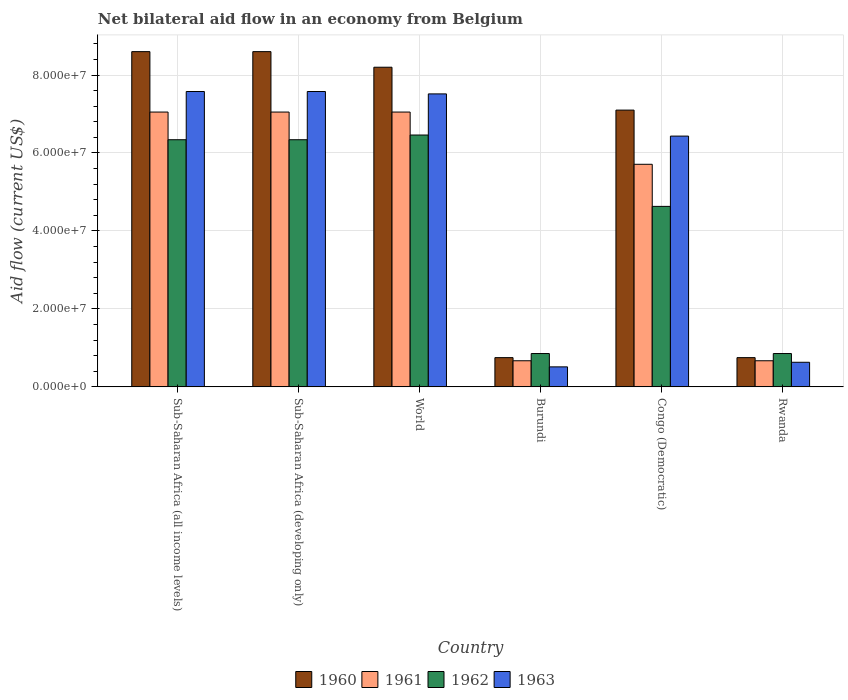Are the number of bars per tick equal to the number of legend labels?
Provide a succinct answer. Yes. Are the number of bars on each tick of the X-axis equal?
Provide a short and direct response. Yes. How many bars are there on the 4th tick from the left?
Your answer should be very brief. 4. What is the label of the 4th group of bars from the left?
Give a very brief answer. Burundi. What is the net bilateral aid flow in 1963 in Burundi?
Keep it short and to the point. 5.13e+06. Across all countries, what is the maximum net bilateral aid flow in 1961?
Give a very brief answer. 7.05e+07. Across all countries, what is the minimum net bilateral aid flow in 1962?
Your response must be concise. 8.55e+06. In which country was the net bilateral aid flow in 1960 maximum?
Make the answer very short. Sub-Saharan Africa (all income levels). In which country was the net bilateral aid flow in 1960 minimum?
Your answer should be very brief. Burundi. What is the total net bilateral aid flow in 1961 in the graph?
Make the answer very short. 2.82e+08. What is the difference between the net bilateral aid flow in 1963 in Congo (Democratic) and that in World?
Keep it short and to the point. -1.08e+07. What is the difference between the net bilateral aid flow in 1962 in Congo (Democratic) and the net bilateral aid flow in 1963 in Sub-Saharan Africa (all income levels)?
Provide a short and direct response. -2.95e+07. What is the average net bilateral aid flow in 1963 per country?
Your answer should be compact. 5.04e+07. What is the difference between the net bilateral aid flow of/in 1961 and net bilateral aid flow of/in 1963 in Sub-Saharan Africa (all income levels)?
Keep it short and to the point. -5.27e+06. What is the ratio of the net bilateral aid flow in 1960 in Congo (Democratic) to that in Sub-Saharan Africa (all income levels)?
Offer a very short reply. 0.83. What is the difference between the highest and the second highest net bilateral aid flow in 1962?
Your answer should be very brief. 1.21e+06. What is the difference between the highest and the lowest net bilateral aid flow in 1962?
Keep it short and to the point. 5.61e+07. In how many countries, is the net bilateral aid flow in 1960 greater than the average net bilateral aid flow in 1960 taken over all countries?
Your answer should be compact. 4. Is the sum of the net bilateral aid flow in 1961 in Burundi and Sub-Saharan Africa (developing only) greater than the maximum net bilateral aid flow in 1963 across all countries?
Make the answer very short. Yes. How many bars are there?
Provide a succinct answer. 24. How many countries are there in the graph?
Your answer should be very brief. 6. What is the difference between two consecutive major ticks on the Y-axis?
Your response must be concise. 2.00e+07. Are the values on the major ticks of Y-axis written in scientific E-notation?
Your answer should be very brief. Yes. Does the graph contain any zero values?
Ensure brevity in your answer.  No. Does the graph contain grids?
Keep it short and to the point. Yes. Where does the legend appear in the graph?
Keep it short and to the point. Bottom center. What is the title of the graph?
Offer a terse response. Net bilateral aid flow in an economy from Belgium. Does "2002" appear as one of the legend labels in the graph?
Keep it short and to the point. No. What is the label or title of the X-axis?
Provide a succinct answer. Country. What is the label or title of the Y-axis?
Your response must be concise. Aid flow (current US$). What is the Aid flow (current US$) in 1960 in Sub-Saharan Africa (all income levels)?
Provide a succinct answer. 8.60e+07. What is the Aid flow (current US$) of 1961 in Sub-Saharan Africa (all income levels)?
Ensure brevity in your answer.  7.05e+07. What is the Aid flow (current US$) of 1962 in Sub-Saharan Africa (all income levels)?
Offer a terse response. 6.34e+07. What is the Aid flow (current US$) of 1963 in Sub-Saharan Africa (all income levels)?
Offer a very short reply. 7.58e+07. What is the Aid flow (current US$) of 1960 in Sub-Saharan Africa (developing only)?
Provide a short and direct response. 8.60e+07. What is the Aid flow (current US$) in 1961 in Sub-Saharan Africa (developing only)?
Your answer should be very brief. 7.05e+07. What is the Aid flow (current US$) of 1962 in Sub-Saharan Africa (developing only)?
Provide a succinct answer. 6.34e+07. What is the Aid flow (current US$) of 1963 in Sub-Saharan Africa (developing only)?
Give a very brief answer. 7.58e+07. What is the Aid flow (current US$) in 1960 in World?
Ensure brevity in your answer.  8.20e+07. What is the Aid flow (current US$) of 1961 in World?
Provide a succinct answer. 7.05e+07. What is the Aid flow (current US$) of 1962 in World?
Provide a short and direct response. 6.46e+07. What is the Aid flow (current US$) in 1963 in World?
Provide a short and direct response. 7.52e+07. What is the Aid flow (current US$) of 1960 in Burundi?
Offer a terse response. 7.50e+06. What is the Aid flow (current US$) in 1961 in Burundi?
Offer a very short reply. 6.70e+06. What is the Aid flow (current US$) of 1962 in Burundi?
Provide a short and direct response. 8.55e+06. What is the Aid flow (current US$) in 1963 in Burundi?
Offer a very short reply. 5.13e+06. What is the Aid flow (current US$) in 1960 in Congo (Democratic)?
Offer a terse response. 7.10e+07. What is the Aid flow (current US$) of 1961 in Congo (Democratic)?
Offer a very short reply. 5.71e+07. What is the Aid flow (current US$) of 1962 in Congo (Democratic)?
Offer a terse response. 4.63e+07. What is the Aid flow (current US$) of 1963 in Congo (Democratic)?
Offer a terse response. 6.43e+07. What is the Aid flow (current US$) of 1960 in Rwanda?
Provide a short and direct response. 7.50e+06. What is the Aid flow (current US$) in 1961 in Rwanda?
Your response must be concise. 6.70e+06. What is the Aid flow (current US$) of 1962 in Rwanda?
Offer a very short reply. 8.55e+06. What is the Aid flow (current US$) in 1963 in Rwanda?
Provide a succinct answer. 6.31e+06. Across all countries, what is the maximum Aid flow (current US$) in 1960?
Make the answer very short. 8.60e+07. Across all countries, what is the maximum Aid flow (current US$) in 1961?
Provide a short and direct response. 7.05e+07. Across all countries, what is the maximum Aid flow (current US$) in 1962?
Offer a terse response. 6.46e+07. Across all countries, what is the maximum Aid flow (current US$) of 1963?
Keep it short and to the point. 7.58e+07. Across all countries, what is the minimum Aid flow (current US$) in 1960?
Your response must be concise. 7.50e+06. Across all countries, what is the minimum Aid flow (current US$) in 1961?
Provide a succinct answer. 6.70e+06. Across all countries, what is the minimum Aid flow (current US$) in 1962?
Offer a terse response. 8.55e+06. Across all countries, what is the minimum Aid flow (current US$) of 1963?
Offer a terse response. 5.13e+06. What is the total Aid flow (current US$) of 1960 in the graph?
Your answer should be very brief. 3.40e+08. What is the total Aid flow (current US$) of 1961 in the graph?
Provide a short and direct response. 2.82e+08. What is the total Aid flow (current US$) in 1962 in the graph?
Offer a terse response. 2.55e+08. What is the total Aid flow (current US$) of 1963 in the graph?
Provide a succinct answer. 3.02e+08. What is the difference between the Aid flow (current US$) in 1960 in Sub-Saharan Africa (all income levels) and that in Sub-Saharan Africa (developing only)?
Your answer should be compact. 0. What is the difference between the Aid flow (current US$) in 1961 in Sub-Saharan Africa (all income levels) and that in Sub-Saharan Africa (developing only)?
Your response must be concise. 0. What is the difference between the Aid flow (current US$) in 1962 in Sub-Saharan Africa (all income levels) and that in Sub-Saharan Africa (developing only)?
Make the answer very short. 0. What is the difference between the Aid flow (current US$) of 1963 in Sub-Saharan Africa (all income levels) and that in Sub-Saharan Africa (developing only)?
Your answer should be very brief. 0. What is the difference between the Aid flow (current US$) in 1962 in Sub-Saharan Africa (all income levels) and that in World?
Offer a terse response. -1.21e+06. What is the difference between the Aid flow (current US$) in 1963 in Sub-Saharan Africa (all income levels) and that in World?
Provide a short and direct response. 6.10e+05. What is the difference between the Aid flow (current US$) of 1960 in Sub-Saharan Africa (all income levels) and that in Burundi?
Give a very brief answer. 7.85e+07. What is the difference between the Aid flow (current US$) in 1961 in Sub-Saharan Africa (all income levels) and that in Burundi?
Provide a short and direct response. 6.38e+07. What is the difference between the Aid flow (current US$) of 1962 in Sub-Saharan Africa (all income levels) and that in Burundi?
Make the answer very short. 5.48e+07. What is the difference between the Aid flow (current US$) in 1963 in Sub-Saharan Africa (all income levels) and that in Burundi?
Keep it short and to the point. 7.06e+07. What is the difference between the Aid flow (current US$) of 1960 in Sub-Saharan Africa (all income levels) and that in Congo (Democratic)?
Offer a very short reply. 1.50e+07. What is the difference between the Aid flow (current US$) in 1961 in Sub-Saharan Africa (all income levels) and that in Congo (Democratic)?
Your response must be concise. 1.34e+07. What is the difference between the Aid flow (current US$) in 1962 in Sub-Saharan Africa (all income levels) and that in Congo (Democratic)?
Ensure brevity in your answer.  1.71e+07. What is the difference between the Aid flow (current US$) of 1963 in Sub-Saharan Africa (all income levels) and that in Congo (Democratic)?
Make the answer very short. 1.14e+07. What is the difference between the Aid flow (current US$) of 1960 in Sub-Saharan Africa (all income levels) and that in Rwanda?
Offer a terse response. 7.85e+07. What is the difference between the Aid flow (current US$) of 1961 in Sub-Saharan Africa (all income levels) and that in Rwanda?
Ensure brevity in your answer.  6.38e+07. What is the difference between the Aid flow (current US$) of 1962 in Sub-Saharan Africa (all income levels) and that in Rwanda?
Your answer should be very brief. 5.48e+07. What is the difference between the Aid flow (current US$) in 1963 in Sub-Saharan Africa (all income levels) and that in Rwanda?
Ensure brevity in your answer.  6.95e+07. What is the difference between the Aid flow (current US$) in 1960 in Sub-Saharan Africa (developing only) and that in World?
Ensure brevity in your answer.  4.00e+06. What is the difference between the Aid flow (current US$) in 1961 in Sub-Saharan Africa (developing only) and that in World?
Provide a short and direct response. 0. What is the difference between the Aid flow (current US$) in 1962 in Sub-Saharan Africa (developing only) and that in World?
Your answer should be very brief. -1.21e+06. What is the difference between the Aid flow (current US$) of 1963 in Sub-Saharan Africa (developing only) and that in World?
Keep it short and to the point. 6.10e+05. What is the difference between the Aid flow (current US$) of 1960 in Sub-Saharan Africa (developing only) and that in Burundi?
Make the answer very short. 7.85e+07. What is the difference between the Aid flow (current US$) in 1961 in Sub-Saharan Africa (developing only) and that in Burundi?
Your answer should be compact. 6.38e+07. What is the difference between the Aid flow (current US$) of 1962 in Sub-Saharan Africa (developing only) and that in Burundi?
Keep it short and to the point. 5.48e+07. What is the difference between the Aid flow (current US$) of 1963 in Sub-Saharan Africa (developing only) and that in Burundi?
Give a very brief answer. 7.06e+07. What is the difference between the Aid flow (current US$) in 1960 in Sub-Saharan Africa (developing only) and that in Congo (Democratic)?
Give a very brief answer. 1.50e+07. What is the difference between the Aid flow (current US$) in 1961 in Sub-Saharan Africa (developing only) and that in Congo (Democratic)?
Make the answer very short. 1.34e+07. What is the difference between the Aid flow (current US$) of 1962 in Sub-Saharan Africa (developing only) and that in Congo (Democratic)?
Offer a very short reply. 1.71e+07. What is the difference between the Aid flow (current US$) of 1963 in Sub-Saharan Africa (developing only) and that in Congo (Democratic)?
Offer a terse response. 1.14e+07. What is the difference between the Aid flow (current US$) of 1960 in Sub-Saharan Africa (developing only) and that in Rwanda?
Provide a short and direct response. 7.85e+07. What is the difference between the Aid flow (current US$) of 1961 in Sub-Saharan Africa (developing only) and that in Rwanda?
Make the answer very short. 6.38e+07. What is the difference between the Aid flow (current US$) of 1962 in Sub-Saharan Africa (developing only) and that in Rwanda?
Provide a succinct answer. 5.48e+07. What is the difference between the Aid flow (current US$) in 1963 in Sub-Saharan Africa (developing only) and that in Rwanda?
Ensure brevity in your answer.  6.95e+07. What is the difference between the Aid flow (current US$) of 1960 in World and that in Burundi?
Keep it short and to the point. 7.45e+07. What is the difference between the Aid flow (current US$) of 1961 in World and that in Burundi?
Provide a short and direct response. 6.38e+07. What is the difference between the Aid flow (current US$) in 1962 in World and that in Burundi?
Offer a terse response. 5.61e+07. What is the difference between the Aid flow (current US$) in 1963 in World and that in Burundi?
Keep it short and to the point. 7.00e+07. What is the difference between the Aid flow (current US$) in 1960 in World and that in Congo (Democratic)?
Ensure brevity in your answer.  1.10e+07. What is the difference between the Aid flow (current US$) of 1961 in World and that in Congo (Democratic)?
Offer a very short reply. 1.34e+07. What is the difference between the Aid flow (current US$) in 1962 in World and that in Congo (Democratic)?
Offer a very short reply. 1.83e+07. What is the difference between the Aid flow (current US$) in 1963 in World and that in Congo (Democratic)?
Make the answer very short. 1.08e+07. What is the difference between the Aid flow (current US$) in 1960 in World and that in Rwanda?
Provide a succinct answer. 7.45e+07. What is the difference between the Aid flow (current US$) in 1961 in World and that in Rwanda?
Give a very brief answer. 6.38e+07. What is the difference between the Aid flow (current US$) of 1962 in World and that in Rwanda?
Offer a very short reply. 5.61e+07. What is the difference between the Aid flow (current US$) of 1963 in World and that in Rwanda?
Provide a succinct answer. 6.88e+07. What is the difference between the Aid flow (current US$) in 1960 in Burundi and that in Congo (Democratic)?
Offer a terse response. -6.35e+07. What is the difference between the Aid flow (current US$) in 1961 in Burundi and that in Congo (Democratic)?
Provide a short and direct response. -5.04e+07. What is the difference between the Aid flow (current US$) of 1962 in Burundi and that in Congo (Democratic)?
Ensure brevity in your answer.  -3.78e+07. What is the difference between the Aid flow (current US$) in 1963 in Burundi and that in Congo (Democratic)?
Make the answer very short. -5.92e+07. What is the difference between the Aid flow (current US$) of 1963 in Burundi and that in Rwanda?
Give a very brief answer. -1.18e+06. What is the difference between the Aid flow (current US$) in 1960 in Congo (Democratic) and that in Rwanda?
Provide a succinct answer. 6.35e+07. What is the difference between the Aid flow (current US$) in 1961 in Congo (Democratic) and that in Rwanda?
Ensure brevity in your answer.  5.04e+07. What is the difference between the Aid flow (current US$) in 1962 in Congo (Democratic) and that in Rwanda?
Ensure brevity in your answer.  3.78e+07. What is the difference between the Aid flow (current US$) of 1963 in Congo (Democratic) and that in Rwanda?
Offer a terse response. 5.80e+07. What is the difference between the Aid flow (current US$) of 1960 in Sub-Saharan Africa (all income levels) and the Aid flow (current US$) of 1961 in Sub-Saharan Africa (developing only)?
Offer a terse response. 1.55e+07. What is the difference between the Aid flow (current US$) in 1960 in Sub-Saharan Africa (all income levels) and the Aid flow (current US$) in 1962 in Sub-Saharan Africa (developing only)?
Your answer should be compact. 2.26e+07. What is the difference between the Aid flow (current US$) of 1960 in Sub-Saharan Africa (all income levels) and the Aid flow (current US$) of 1963 in Sub-Saharan Africa (developing only)?
Provide a short and direct response. 1.02e+07. What is the difference between the Aid flow (current US$) of 1961 in Sub-Saharan Africa (all income levels) and the Aid flow (current US$) of 1962 in Sub-Saharan Africa (developing only)?
Your answer should be compact. 7.10e+06. What is the difference between the Aid flow (current US$) in 1961 in Sub-Saharan Africa (all income levels) and the Aid flow (current US$) in 1963 in Sub-Saharan Africa (developing only)?
Offer a very short reply. -5.27e+06. What is the difference between the Aid flow (current US$) of 1962 in Sub-Saharan Africa (all income levels) and the Aid flow (current US$) of 1963 in Sub-Saharan Africa (developing only)?
Make the answer very short. -1.24e+07. What is the difference between the Aid flow (current US$) in 1960 in Sub-Saharan Africa (all income levels) and the Aid flow (current US$) in 1961 in World?
Ensure brevity in your answer.  1.55e+07. What is the difference between the Aid flow (current US$) in 1960 in Sub-Saharan Africa (all income levels) and the Aid flow (current US$) in 1962 in World?
Keep it short and to the point. 2.14e+07. What is the difference between the Aid flow (current US$) of 1960 in Sub-Saharan Africa (all income levels) and the Aid flow (current US$) of 1963 in World?
Provide a succinct answer. 1.08e+07. What is the difference between the Aid flow (current US$) in 1961 in Sub-Saharan Africa (all income levels) and the Aid flow (current US$) in 1962 in World?
Ensure brevity in your answer.  5.89e+06. What is the difference between the Aid flow (current US$) of 1961 in Sub-Saharan Africa (all income levels) and the Aid flow (current US$) of 1963 in World?
Offer a terse response. -4.66e+06. What is the difference between the Aid flow (current US$) in 1962 in Sub-Saharan Africa (all income levels) and the Aid flow (current US$) in 1963 in World?
Provide a succinct answer. -1.18e+07. What is the difference between the Aid flow (current US$) of 1960 in Sub-Saharan Africa (all income levels) and the Aid flow (current US$) of 1961 in Burundi?
Ensure brevity in your answer.  7.93e+07. What is the difference between the Aid flow (current US$) of 1960 in Sub-Saharan Africa (all income levels) and the Aid flow (current US$) of 1962 in Burundi?
Offer a terse response. 7.74e+07. What is the difference between the Aid flow (current US$) in 1960 in Sub-Saharan Africa (all income levels) and the Aid flow (current US$) in 1963 in Burundi?
Your response must be concise. 8.09e+07. What is the difference between the Aid flow (current US$) in 1961 in Sub-Saharan Africa (all income levels) and the Aid flow (current US$) in 1962 in Burundi?
Provide a short and direct response. 6.20e+07. What is the difference between the Aid flow (current US$) of 1961 in Sub-Saharan Africa (all income levels) and the Aid flow (current US$) of 1963 in Burundi?
Make the answer very short. 6.54e+07. What is the difference between the Aid flow (current US$) in 1962 in Sub-Saharan Africa (all income levels) and the Aid flow (current US$) in 1963 in Burundi?
Offer a very short reply. 5.83e+07. What is the difference between the Aid flow (current US$) in 1960 in Sub-Saharan Africa (all income levels) and the Aid flow (current US$) in 1961 in Congo (Democratic)?
Offer a very short reply. 2.89e+07. What is the difference between the Aid flow (current US$) in 1960 in Sub-Saharan Africa (all income levels) and the Aid flow (current US$) in 1962 in Congo (Democratic)?
Your response must be concise. 3.97e+07. What is the difference between the Aid flow (current US$) in 1960 in Sub-Saharan Africa (all income levels) and the Aid flow (current US$) in 1963 in Congo (Democratic)?
Give a very brief answer. 2.17e+07. What is the difference between the Aid flow (current US$) in 1961 in Sub-Saharan Africa (all income levels) and the Aid flow (current US$) in 1962 in Congo (Democratic)?
Keep it short and to the point. 2.42e+07. What is the difference between the Aid flow (current US$) of 1961 in Sub-Saharan Africa (all income levels) and the Aid flow (current US$) of 1963 in Congo (Democratic)?
Provide a succinct answer. 6.17e+06. What is the difference between the Aid flow (current US$) in 1962 in Sub-Saharan Africa (all income levels) and the Aid flow (current US$) in 1963 in Congo (Democratic)?
Your answer should be compact. -9.30e+05. What is the difference between the Aid flow (current US$) in 1960 in Sub-Saharan Africa (all income levels) and the Aid flow (current US$) in 1961 in Rwanda?
Provide a short and direct response. 7.93e+07. What is the difference between the Aid flow (current US$) of 1960 in Sub-Saharan Africa (all income levels) and the Aid flow (current US$) of 1962 in Rwanda?
Give a very brief answer. 7.74e+07. What is the difference between the Aid flow (current US$) in 1960 in Sub-Saharan Africa (all income levels) and the Aid flow (current US$) in 1963 in Rwanda?
Provide a short and direct response. 7.97e+07. What is the difference between the Aid flow (current US$) in 1961 in Sub-Saharan Africa (all income levels) and the Aid flow (current US$) in 1962 in Rwanda?
Give a very brief answer. 6.20e+07. What is the difference between the Aid flow (current US$) of 1961 in Sub-Saharan Africa (all income levels) and the Aid flow (current US$) of 1963 in Rwanda?
Your response must be concise. 6.42e+07. What is the difference between the Aid flow (current US$) of 1962 in Sub-Saharan Africa (all income levels) and the Aid flow (current US$) of 1963 in Rwanda?
Offer a very short reply. 5.71e+07. What is the difference between the Aid flow (current US$) in 1960 in Sub-Saharan Africa (developing only) and the Aid flow (current US$) in 1961 in World?
Keep it short and to the point. 1.55e+07. What is the difference between the Aid flow (current US$) of 1960 in Sub-Saharan Africa (developing only) and the Aid flow (current US$) of 1962 in World?
Make the answer very short. 2.14e+07. What is the difference between the Aid flow (current US$) of 1960 in Sub-Saharan Africa (developing only) and the Aid flow (current US$) of 1963 in World?
Your response must be concise. 1.08e+07. What is the difference between the Aid flow (current US$) in 1961 in Sub-Saharan Africa (developing only) and the Aid flow (current US$) in 1962 in World?
Offer a very short reply. 5.89e+06. What is the difference between the Aid flow (current US$) of 1961 in Sub-Saharan Africa (developing only) and the Aid flow (current US$) of 1963 in World?
Provide a succinct answer. -4.66e+06. What is the difference between the Aid flow (current US$) in 1962 in Sub-Saharan Africa (developing only) and the Aid flow (current US$) in 1963 in World?
Provide a short and direct response. -1.18e+07. What is the difference between the Aid flow (current US$) of 1960 in Sub-Saharan Africa (developing only) and the Aid flow (current US$) of 1961 in Burundi?
Offer a terse response. 7.93e+07. What is the difference between the Aid flow (current US$) in 1960 in Sub-Saharan Africa (developing only) and the Aid flow (current US$) in 1962 in Burundi?
Make the answer very short. 7.74e+07. What is the difference between the Aid flow (current US$) of 1960 in Sub-Saharan Africa (developing only) and the Aid flow (current US$) of 1963 in Burundi?
Offer a terse response. 8.09e+07. What is the difference between the Aid flow (current US$) in 1961 in Sub-Saharan Africa (developing only) and the Aid flow (current US$) in 1962 in Burundi?
Offer a very short reply. 6.20e+07. What is the difference between the Aid flow (current US$) of 1961 in Sub-Saharan Africa (developing only) and the Aid flow (current US$) of 1963 in Burundi?
Give a very brief answer. 6.54e+07. What is the difference between the Aid flow (current US$) of 1962 in Sub-Saharan Africa (developing only) and the Aid flow (current US$) of 1963 in Burundi?
Ensure brevity in your answer.  5.83e+07. What is the difference between the Aid flow (current US$) in 1960 in Sub-Saharan Africa (developing only) and the Aid flow (current US$) in 1961 in Congo (Democratic)?
Make the answer very short. 2.89e+07. What is the difference between the Aid flow (current US$) in 1960 in Sub-Saharan Africa (developing only) and the Aid flow (current US$) in 1962 in Congo (Democratic)?
Give a very brief answer. 3.97e+07. What is the difference between the Aid flow (current US$) in 1960 in Sub-Saharan Africa (developing only) and the Aid flow (current US$) in 1963 in Congo (Democratic)?
Make the answer very short. 2.17e+07. What is the difference between the Aid flow (current US$) in 1961 in Sub-Saharan Africa (developing only) and the Aid flow (current US$) in 1962 in Congo (Democratic)?
Offer a terse response. 2.42e+07. What is the difference between the Aid flow (current US$) of 1961 in Sub-Saharan Africa (developing only) and the Aid flow (current US$) of 1963 in Congo (Democratic)?
Your response must be concise. 6.17e+06. What is the difference between the Aid flow (current US$) in 1962 in Sub-Saharan Africa (developing only) and the Aid flow (current US$) in 1963 in Congo (Democratic)?
Keep it short and to the point. -9.30e+05. What is the difference between the Aid flow (current US$) in 1960 in Sub-Saharan Africa (developing only) and the Aid flow (current US$) in 1961 in Rwanda?
Provide a succinct answer. 7.93e+07. What is the difference between the Aid flow (current US$) of 1960 in Sub-Saharan Africa (developing only) and the Aid flow (current US$) of 1962 in Rwanda?
Your response must be concise. 7.74e+07. What is the difference between the Aid flow (current US$) of 1960 in Sub-Saharan Africa (developing only) and the Aid flow (current US$) of 1963 in Rwanda?
Your response must be concise. 7.97e+07. What is the difference between the Aid flow (current US$) in 1961 in Sub-Saharan Africa (developing only) and the Aid flow (current US$) in 1962 in Rwanda?
Keep it short and to the point. 6.20e+07. What is the difference between the Aid flow (current US$) in 1961 in Sub-Saharan Africa (developing only) and the Aid flow (current US$) in 1963 in Rwanda?
Offer a very short reply. 6.42e+07. What is the difference between the Aid flow (current US$) in 1962 in Sub-Saharan Africa (developing only) and the Aid flow (current US$) in 1963 in Rwanda?
Offer a terse response. 5.71e+07. What is the difference between the Aid flow (current US$) in 1960 in World and the Aid flow (current US$) in 1961 in Burundi?
Your answer should be compact. 7.53e+07. What is the difference between the Aid flow (current US$) in 1960 in World and the Aid flow (current US$) in 1962 in Burundi?
Ensure brevity in your answer.  7.34e+07. What is the difference between the Aid flow (current US$) of 1960 in World and the Aid flow (current US$) of 1963 in Burundi?
Offer a very short reply. 7.69e+07. What is the difference between the Aid flow (current US$) in 1961 in World and the Aid flow (current US$) in 1962 in Burundi?
Your answer should be very brief. 6.20e+07. What is the difference between the Aid flow (current US$) of 1961 in World and the Aid flow (current US$) of 1963 in Burundi?
Your response must be concise. 6.54e+07. What is the difference between the Aid flow (current US$) of 1962 in World and the Aid flow (current US$) of 1963 in Burundi?
Your answer should be compact. 5.95e+07. What is the difference between the Aid flow (current US$) of 1960 in World and the Aid flow (current US$) of 1961 in Congo (Democratic)?
Your answer should be compact. 2.49e+07. What is the difference between the Aid flow (current US$) of 1960 in World and the Aid flow (current US$) of 1962 in Congo (Democratic)?
Provide a succinct answer. 3.57e+07. What is the difference between the Aid flow (current US$) of 1960 in World and the Aid flow (current US$) of 1963 in Congo (Democratic)?
Make the answer very short. 1.77e+07. What is the difference between the Aid flow (current US$) of 1961 in World and the Aid flow (current US$) of 1962 in Congo (Democratic)?
Keep it short and to the point. 2.42e+07. What is the difference between the Aid flow (current US$) in 1961 in World and the Aid flow (current US$) in 1963 in Congo (Democratic)?
Give a very brief answer. 6.17e+06. What is the difference between the Aid flow (current US$) of 1960 in World and the Aid flow (current US$) of 1961 in Rwanda?
Offer a very short reply. 7.53e+07. What is the difference between the Aid flow (current US$) of 1960 in World and the Aid flow (current US$) of 1962 in Rwanda?
Keep it short and to the point. 7.34e+07. What is the difference between the Aid flow (current US$) in 1960 in World and the Aid flow (current US$) in 1963 in Rwanda?
Ensure brevity in your answer.  7.57e+07. What is the difference between the Aid flow (current US$) of 1961 in World and the Aid flow (current US$) of 1962 in Rwanda?
Your response must be concise. 6.20e+07. What is the difference between the Aid flow (current US$) of 1961 in World and the Aid flow (current US$) of 1963 in Rwanda?
Your answer should be compact. 6.42e+07. What is the difference between the Aid flow (current US$) of 1962 in World and the Aid flow (current US$) of 1963 in Rwanda?
Your response must be concise. 5.83e+07. What is the difference between the Aid flow (current US$) in 1960 in Burundi and the Aid flow (current US$) in 1961 in Congo (Democratic)?
Provide a succinct answer. -4.96e+07. What is the difference between the Aid flow (current US$) of 1960 in Burundi and the Aid flow (current US$) of 1962 in Congo (Democratic)?
Ensure brevity in your answer.  -3.88e+07. What is the difference between the Aid flow (current US$) in 1960 in Burundi and the Aid flow (current US$) in 1963 in Congo (Democratic)?
Give a very brief answer. -5.68e+07. What is the difference between the Aid flow (current US$) of 1961 in Burundi and the Aid flow (current US$) of 1962 in Congo (Democratic)?
Provide a succinct answer. -3.96e+07. What is the difference between the Aid flow (current US$) of 1961 in Burundi and the Aid flow (current US$) of 1963 in Congo (Democratic)?
Give a very brief answer. -5.76e+07. What is the difference between the Aid flow (current US$) in 1962 in Burundi and the Aid flow (current US$) in 1963 in Congo (Democratic)?
Provide a succinct answer. -5.58e+07. What is the difference between the Aid flow (current US$) in 1960 in Burundi and the Aid flow (current US$) in 1962 in Rwanda?
Provide a succinct answer. -1.05e+06. What is the difference between the Aid flow (current US$) in 1960 in Burundi and the Aid flow (current US$) in 1963 in Rwanda?
Your answer should be compact. 1.19e+06. What is the difference between the Aid flow (current US$) in 1961 in Burundi and the Aid flow (current US$) in 1962 in Rwanda?
Your response must be concise. -1.85e+06. What is the difference between the Aid flow (current US$) in 1962 in Burundi and the Aid flow (current US$) in 1963 in Rwanda?
Give a very brief answer. 2.24e+06. What is the difference between the Aid flow (current US$) in 1960 in Congo (Democratic) and the Aid flow (current US$) in 1961 in Rwanda?
Provide a short and direct response. 6.43e+07. What is the difference between the Aid flow (current US$) in 1960 in Congo (Democratic) and the Aid flow (current US$) in 1962 in Rwanda?
Give a very brief answer. 6.24e+07. What is the difference between the Aid flow (current US$) in 1960 in Congo (Democratic) and the Aid flow (current US$) in 1963 in Rwanda?
Give a very brief answer. 6.47e+07. What is the difference between the Aid flow (current US$) in 1961 in Congo (Democratic) and the Aid flow (current US$) in 1962 in Rwanda?
Your answer should be very brief. 4.86e+07. What is the difference between the Aid flow (current US$) of 1961 in Congo (Democratic) and the Aid flow (current US$) of 1963 in Rwanda?
Provide a succinct answer. 5.08e+07. What is the difference between the Aid flow (current US$) of 1962 in Congo (Democratic) and the Aid flow (current US$) of 1963 in Rwanda?
Make the answer very short. 4.00e+07. What is the average Aid flow (current US$) in 1960 per country?
Provide a short and direct response. 5.67e+07. What is the average Aid flow (current US$) of 1961 per country?
Keep it short and to the point. 4.70e+07. What is the average Aid flow (current US$) in 1962 per country?
Give a very brief answer. 4.25e+07. What is the average Aid flow (current US$) of 1963 per country?
Provide a succinct answer. 5.04e+07. What is the difference between the Aid flow (current US$) of 1960 and Aid flow (current US$) of 1961 in Sub-Saharan Africa (all income levels)?
Make the answer very short. 1.55e+07. What is the difference between the Aid flow (current US$) in 1960 and Aid flow (current US$) in 1962 in Sub-Saharan Africa (all income levels)?
Make the answer very short. 2.26e+07. What is the difference between the Aid flow (current US$) in 1960 and Aid flow (current US$) in 1963 in Sub-Saharan Africa (all income levels)?
Offer a terse response. 1.02e+07. What is the difference between the Aid flow (current US$) in 1961 and Aid flow (current US$) in 1962 in Sub-Saharan Africa (all income levels)?
Make the answer very short. 7.10e+06. What is the difference between the Aid flow (current US$) of 1961 and Aid flow (current US$) of 1963 in Sub-Saharan Africa (all income levels)?
Keep it short and to the point. -5.27e+06. What is the difference between the Aid flow (current US$) of 1962 and Aid flow (current US$) of 1963 in Sub-Saharan Africa (all income levels)?
Provide a succinct answer. -1.24e+07. What is the difference between the Aid flow (current US$) in 1960 and Aid flow (current US$) in 1961 in Sub-Saharan Africa (developing only)?
Ensure brevity in your answer.  1.55e+07. What is the difference between the Aid flow (current US$) in 1960 and Aid flow (current US$) in 1962 in Sub-Saharan Africa (developing only)?
Offer a terse response. 2.26e+07. What is the difference between the Aid flow (current US$) of 1960 and Aid flow (current US$) of 1963 in Sub-Saharan Africa (developing only)?
Make the answer very short. 1.02e+07. What is the difference between the Aid flow (current US$) of 1961 and Aid flow (current US$) of 1962 in Sub-Saharan Africa (developing only)?
Your answer should be compact. 7.10e+06. What is the difference between the Aid flow (current US$) in 1961 and Aid flow (current US$) in 1963 in Sub-Saharan Africa (developing only)?
Provide a short and direct response. -5.27e+06. What is the difference between the Aid flow (current US$) in 1962 and Aid flow (current US$) in 1963 in Sub-Saharan Africa (developing only)?
Make the answer very short. -1.24e+07. What is the difference between the Aid flow (current US$) in 1960 and Aid flow (current US$) in 1961 in World?
Provide a short and direct response. 1.15e+07. What is the difference between the Aid flow (current US$) of 1960 and Aid flow (current US$) of 1962 in World?
Keep it short and to the point. 1.74e+07. What is the difference between the Aid flow (current US$) in 1960 and Aid flow (current US$) in 1963 in World?
Make the answer very short. 6.84e+06. What is the difference between the Aid flow (current US$) of 1961 and Aid flow (current US$) of 1962 in World?
Give a very brief answer. 5.89e+06. What is the difference between the Aid flow (current US$) of 1961 and Aid flow (current US$) of 1963 in World?
Your answer should be compact. -4.66e+06. What is the difference between the Aid flow (current US$) in 1962 and Aid flow (current US$) in 1963 in World?
Ensure brevity in your answer.  -1.06e+07. What is the difference between the Aid flow (current US$) in 1960 and Aid flow (current US$) in 1962 in Burundi?
Your response must be concise. -1.05e+06. What is the difference between the Aid flow (current US$) in 1960 and Aid flow (current US$) in 1963 in Burundi?
Give a very brief answer. 2.37e+06. What is the difference between the Aid flow (current US$) of 1961 and Aid flow (current US$) of 1962 in Burundi?
Provide a short and direct response. -1.85e+06. What is the difference between the Aid flow (current US$) of 1961 and Aid flow (current US$) of 1963 in Burundi?
Ensure brevity in your answer.  1.57e+06. What is the difference between the Aid flow (current US$) in 1962 and Aid flow (current US$) in 1963 in Burundi?
Provide a succinct answer. 3.42e+06. What is the difference between the Aid flow (current US$) in 1960 and Aid flow (current US$) in 1961 in Congo (Democratic)?
Make the answer very short. 1.39e+07. What is the difference between the Aid flow (current US$) in 1960 and Aid flow (current US$) in 1962 in Congo (Democratic)?
Offer a very short reply. 2.47e+07. What is the difference between the Aid flow (current US$) in 1960 and Aid flow (current US$) in 1963 in Congo (Democratic)?
Give a very brief answer. 6.67e+06. What is the difference between the Aid flow (current US$) of 1961 and Aid flow (current US$) of 1962 in Congo (Democratic)?
Provide a short and direct response. 1.08e+07. What is the difference between the Aid flow (current US$) in 1961 and Aid flow (current US$) in 1963 in Congo (Democratic)?
Give a very brief answer. -7.23e+06. What is the difference between the Aid flow (current US$) in 1962 and Aid flow (current US$) in 1963 in Congo (Democratic)?
Your answer should be very brief. -1.80e+07. What is the difference between the Aid flow (current US$) in 1960 and Aid flow (current US$) in 1961 in Rwanda?
Your response must be concise. 8.00e+05. What is the difference between the Aid flow (current US$) in 1960 and Aid flow (current US$) in 1962 in Rwanda?
Your response must be concise. -1.05e+06. What is the difference between the Aid flow (current US$) of 1960 and Aid flow (current US$) of 1963 in Rwanda?
Make the answer very short. 1.19e+06. What is the difference between the Aid flow (current US$) in 1961 and Aid flow (current US$) in 1962 in Rwanda?
Offer a very short reply. -1.85e+06. What is the difference between the Aid flow (current US$) in 1962 and Aid flow (current US$) in 1963 in Rwanda?
Make the answer very short. 2.24e+06. What is the ratio of the Aid flow (current US$) of 1963 in Sub-Saharan Africa (all income levels) to that in Sub-Saharan Africa (developing only)?
Provide a succinct answer. 1. What is the ratio of the Aid flow (current US$) of 1960 in Sub-Saharan Africa (all income levels) to that in World?
Offer a terse response. 1.05. What is the ratio of the Aid flow (current US$) of 1961 in Sub-Saharan Africa (all income levels) to that in World?
Offer a very short reply. 1. What is the ratio of the Aid flow (current US$) in 1962 in Sub-Saharan Africa (all income levels) to that in World?
Offer a terse response. 0.98. What is the ratio of the Aid flow (current US$) in 1960 in Sub-Saharan Africa (all income levels) to that in Burundi?
Offer a very short reply. 11.47. What is the ratio of the Aid flow (current US$) in 1961 in Sub-Saharan Africa (all income levels) to that in Burundi?
Offer a terse response. 10.52. What is the ratio of the Aid flow (current US$) in 1962 in Sub-Saharan Africa (all income levels) to that in Burundi?
Give a very brief answer. 7.42. What is the ratio of the Aid flow (current US$) of 1963 in Sub-Saharan Africa (all income levels) to that in Burundi?
Provide a short and direct response. 14.77. What is the ratio of the Aid flow (current US$) in 1960 in Sub-Saharan Africa (all income levels) to that in Congo (Democratic)?
Give a very brief answer. 1.21. What is the ratio of the Aid flow (current US$) of 1961 in Sub-Saharan Africa (all income levels) to that in Congo (Democratic)?
Provide a short and direct response. 1.23. What is the ratio of the Aid flow (current US$) in 1962 in Sub-Saharan Africa (all income levels) to that in Congo (Democratic)?
Offer a terse response. 1.37. What is the ratio of the Aid flow (current US$) of 1963 in Sub-Saharan Africa (all income levels) to that in Congo (Democratic)?
Provide a short and direct response. 1.18. What is the ratio of the Aid flow (current US$) of 1960 in Sub-Saharan Africa (all income levels) to that in Rwanda?
Keep it short and to the point. 11.47. What is the ratio of the Aid flow (current US$) in 1961 in Sub-Saharan Africa (all income levels) to that in Rwanda?
Your response must be concise. 10.52. What is the ratio of the Aid flow (current US$) in 1962 in Sub-Saharan Africa (all income levels) to that in Rwanda?
Keep it short and to the point. 7.42. What is the ratio of the Aid flow (current US$) of 1963 in Sub-Saharan Africa (all income levels) to that in Rwanda?
Provide a succinct answer. 12.01. What is the ratio of the Aid flow (current US$) in 1960 in Sub-Saharan Africa (developing only) to that in World?
Give a very brief answer. 1.05. What is the ratio of the Aid flow (current US$) of 1962 in Sub-Saharan Africa (developing only) to that in World?
Keep it short and to the point. 0.98. What is the ratio of the Aid flow (current US$) of 1963 in Sub-Saharan Africa (developing only) to that in World?
Provide a succinct answer. 1.01. What is the ratio of the Aid flow (current US$) in 1960 in Sub-Saharan Africa (developing only) to that in Burundi?
Offer a very short reply. 11.47. What is the ratio of the Aid flow (current US$) of 1961 in Sub-Saharan Africa (developing only) to that in Burundi?
Give a very brief answer. 10.52. What is the ratio of the Aid flow (current US$) of 1962 in Sub-Saharan Africa (developing only) to that in Burundi?
Your response must be concise. 7.42. What is the ratio of the Aid flow (current US$) of 1963 in Sub-Saharan Africa (developing only) to that in Burundi?
Your response must be concise. 14.77. What is the ratio of the Aid flow (current US$) in 1960 in Sub-Saharan Africa (developing only) to that in Congo (Democratic)?
Make the answer very short. 1.21. What is the ratio of the Aid flow (current US$) of 1961 in Sub-Saharan Africa (developing only) to that in Congo (Democratic)?
Your answer should be very brief. 1.23. What is the ratio of the Aid flow (current US$) of 1962 in Sub-Saharan Africa (developing only) to that in Congo (Democratic)?
Offer a very short reply. 1.37. What is the ratio of the Aid flow (current US$) in 1963 in Sub-Saharan Africa (developing only) to that in Congo (Democratic)?
Give a very brief answer. 1.18. What is the ratio of the Aid flow (current US$) of 1960 in Sub-Saharan Africa (developing only) to that in Rwanda?
Your response must be concise. 11.47. What is the ratio of the Aid flow (current US$) in 1961 in Sub-Saharan Africa (developing only) to that in Rwanda?
Your response must be concise. 10.52. What is the ratio of the Aid flow (current US$) of 1962 in Sub-Saharan Africa (developing only) to that in Rwanda?
Your response must be concise. 7.42. What is the ratio of the Aid flow (current US$) of 1963 in Sub-Saharan Africa (developing only) to that in Rwanda?
Keep it short and to the point. 12.01. What is the ratio of the Aid flow (current US$) of 1960 in World to that in Burundi?
Give a very brief answer. 10.93. What is the ratio of the Aid flow (current US$) in 1961 in World to that in Burundi?
Give a very brief answer. 10.52. What is the ratio of the Aid flow (current US$) of 1962 in World to that in Burundi?
Give a very brief answer. 7.56. What is the ratio of the Aid flow (current US$) in 1963 in World to that in Burundi?
Your answer should be compact. 14.65. What is the ratio of the Aid flow (current US$) in 1960 in World to that in Congo (Democratic)?
Offer a very short reply. 1.15. What is the ratio of the Aid flow (current US$) of 1961 in World to that in Congo (Democratic)?
Give a very brief answer. 1.23. What is the ratio of the Aid flow (current US$) in 1962 in World to that in Congo (Democratic)?
Your answer should be very brief. 1.4. What is the ratio of the Aid flow (current US$) of 1963 in World to that in Congo (Democratic)?
Ensure brevity in your answer.  1.17. What is the ratio of the Aid flow (current US$) in 1960 in World to that in Rwanda?
Your answer should be compact. 10.93. What is the ratio of the Aid flow (current US$) in 1961 in World to that in Rwanda?
Your response must be concise. 10.52. What is the ratio of the Aid flow (current US$) of 1962 in World to that in Rwanda?
Keep it short and to the point. 7.56. What is the ratio of the Aid flow (current US$) of 1963 in World to that in Rwanda?
Ensure brevity in your answer.  11.91. What is the ratio of the Aid flow (current US$) in 1960 in Burundi to that in Congo (Democratic)?
Make the answer very short. 0.11. What is the ratio of the Aid flow (current US$) of 1961 in Burundi to that in Congo (Democratic)?
Your answer should be compact. 0.12. What is the ratio of the Aid flow (current US$) in 1962 in Burundi to that in Congo (Democratic)?
Offer a very short reply. 0.18. What is the ratio of the Aid flow (current US$) of 1963 in Burundi to that in Congo (Democratic)?
Ensure brevity in your answer.  0.08. What is the ratio of the Aid flow (current US$) in 1960 in Burundi to that in Rwanda?
Your answer should be compact. 1. What is the ratio of the Aid flow (current US$) in 1961 in Burundi to that in Rwanda?
Your answer should be very brief. 1. What is the ratio of the Aid flow (current US$) in 1963 in Burundi to that in Rwanda?
Keep it short and to the point. 0.81. What is the ratio of the Aid flow (current US$) of 1960 in Congo (Democratic) to that in Rwanda?
Keep it short and to the point. 9.47. What is the ratio of the Aid flow (current US$) in 1961 in Congo (Democratic) to that in Rwanda?
Offer a very short reply. 8.52. What is the ratio of the Aid flow (current US$) of 1962 in Congo (Democratic) to that in Rwanda?
Make the answer very short. 5.42. What is the ratio of the Aid flow (current US$) in 1963 in Congo (Democratic) to that in Rwanda?
Your answer should be compact. 10.19. What is the difference between the highest and the second highest Aid flow (current US$) of 1960?
Ensure brevity in your answer.  0. What is the difference between the highest and the second highest Aid flow (current US$) of 1961?
Provide a short and direct response. 0. What is the difference between the highest and the second highest Aid flow (current US$) of 1962?
Your answer should be very brief. 1.21e+06. What is the difference between the highest and the second highest Aid flow (current US$) in 1963?
Provide a succinct answer. 0. What is the difference between the highest and the lowest Aid flow (current US$) of 1960?
Offer a terse response. 7.85e+07. What is the difference between the highest and the lowest Aid flow (current US$) of 1961?
Offer a terse response. 6.38e+07. What is the difference between the highest and the lowest Aid flow (current US$) in 1962?
Provide a short and direct response. 5.61e+07. What is the difference between the highest and the lowest Aid flow (current US$) in 1963?
Ensure brevity in your answer.  7.06e+07. 